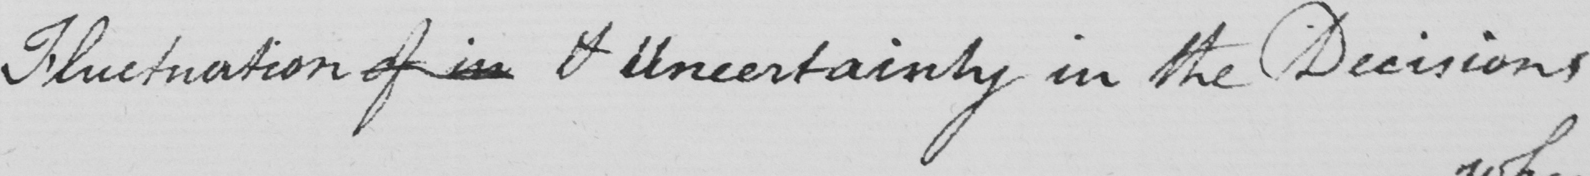What text is written in this handwritten line? Fluctuation of in & Uncertainty in the Decisions 